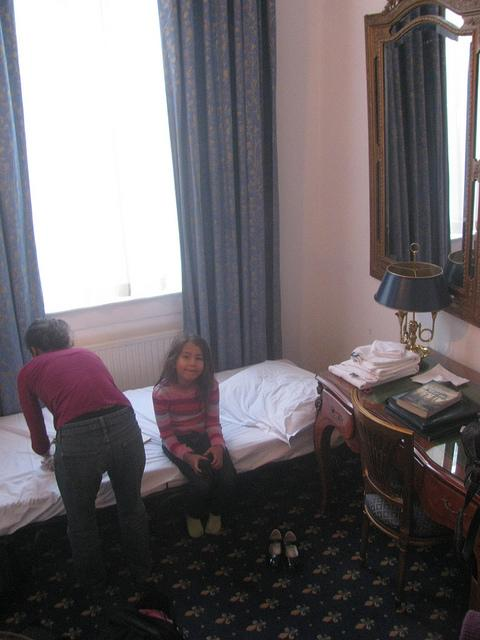Why does she haver her shoes off? Please explain your reasoning. in bed. She is inside a room that is used for sleeping. it would not be appropriate to wear shoes in this setting. 